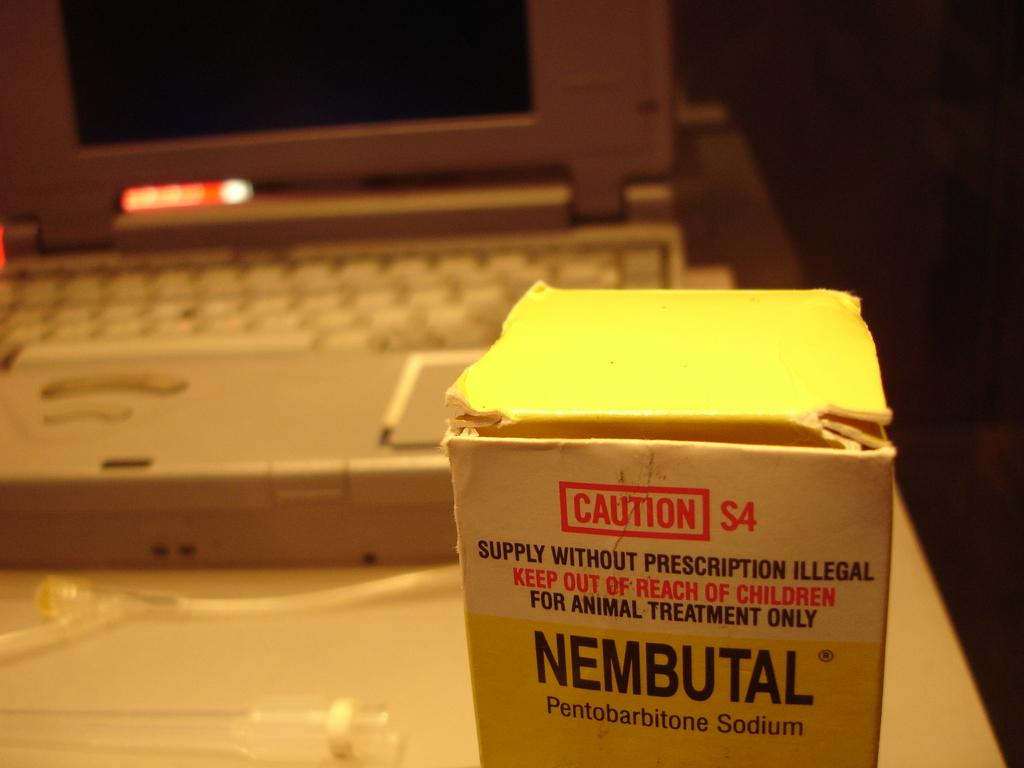What piece of furniture is present in the image? There is a table in the image. What is placed on the table? There is a box and a laptop on the table. Are there any other objects on the table? Yes, there are glass pipes on the table. What can be observed about the color on the right side of the image? The right side of the image appears to be black in color. Can you see any deer interacting with the objects on the table in the image? There are no deer present in the image. What type of grape is being used to create harmony in the image? There is no grape or reference to harmony in the image. 